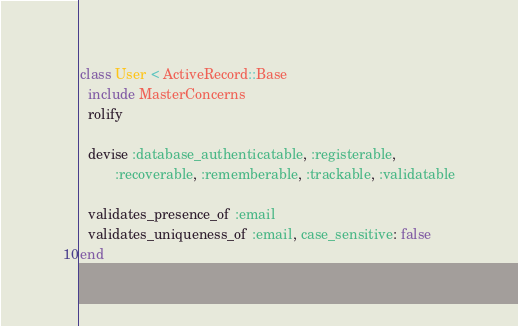Convert code to text. <code><loc_0><loc_0><loc_500><loc_500><_Ruby_>class User < ActiveRecord::Base
  include MasterConcerns
  rolify

  devise :database_authenticatable, :registerable,
         :recoverable, :rememberable, :trackable, :validatable

  validates_presence_of :email
  validates_uniqueness_of :email, case_sensitive: false
end
</code> 